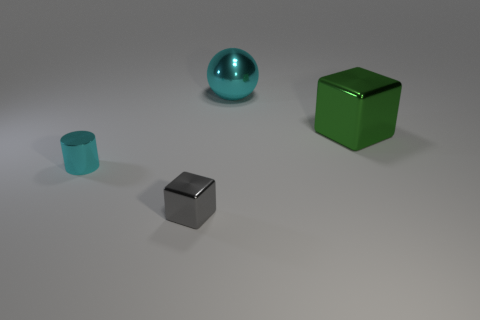Add 2 large green things. How many objects exist? 6 Subtract all balls. How many objects are left? 3 Add 4 large brown metal objects. How many large brown metal objects exist? 4 Subtract 0 red balls. How many objects are left? 4 Subtract all blue cubes. Subtract all red spheres. How many cubes are left? 2 Subtract all tiny blue blocks. Subtract all big blocks. How many objects are left? 3 Add 4 tiny objects. How many tiny objects are left? 6 